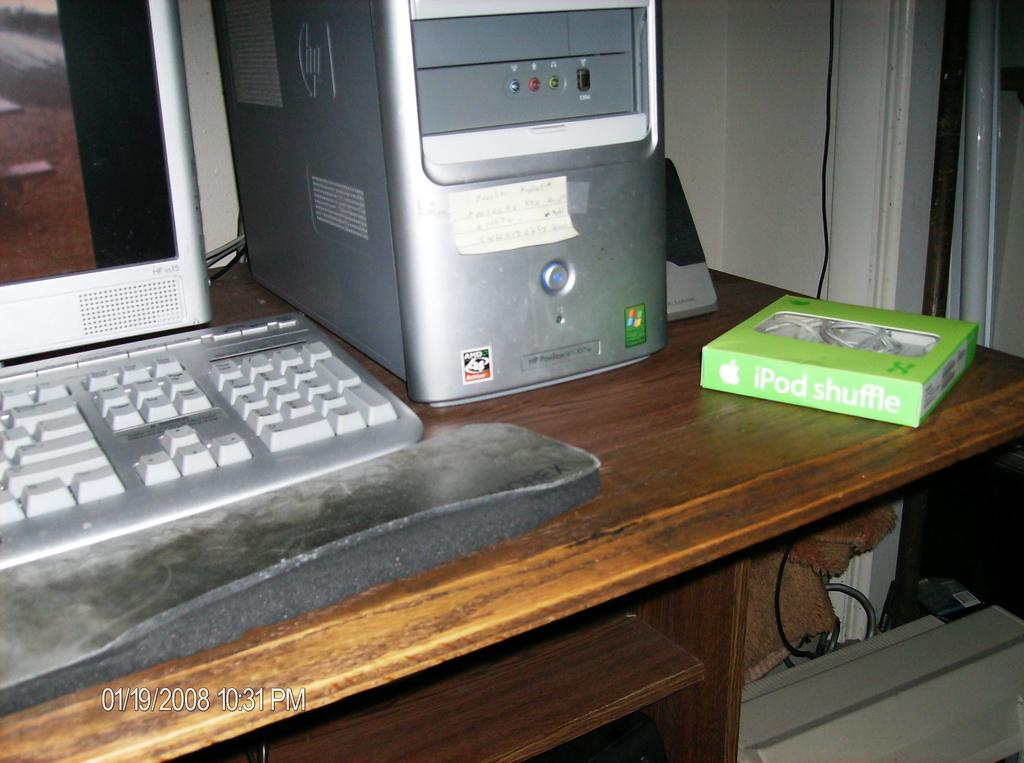What kind of ipod is seen?
Keep it short and to the point. Shuffle. What brand is the desktop computer?
Provide a short and direct response. Hp. 